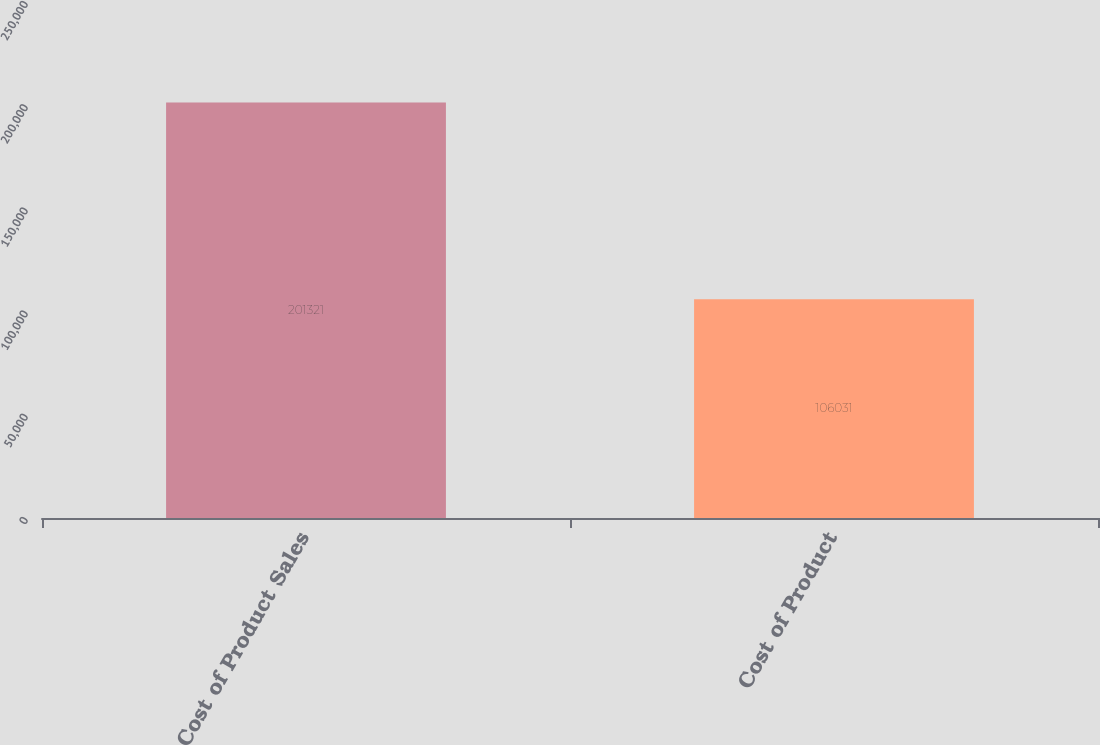Convert chart to OTSL. <chart><loc_0><loc_0><loc_500><loc_500><bar_chart><fcel>Cost of Product Sales<fcel>Cost of Product<nl><fcel>201321<fcel>106031<nl></chart> 